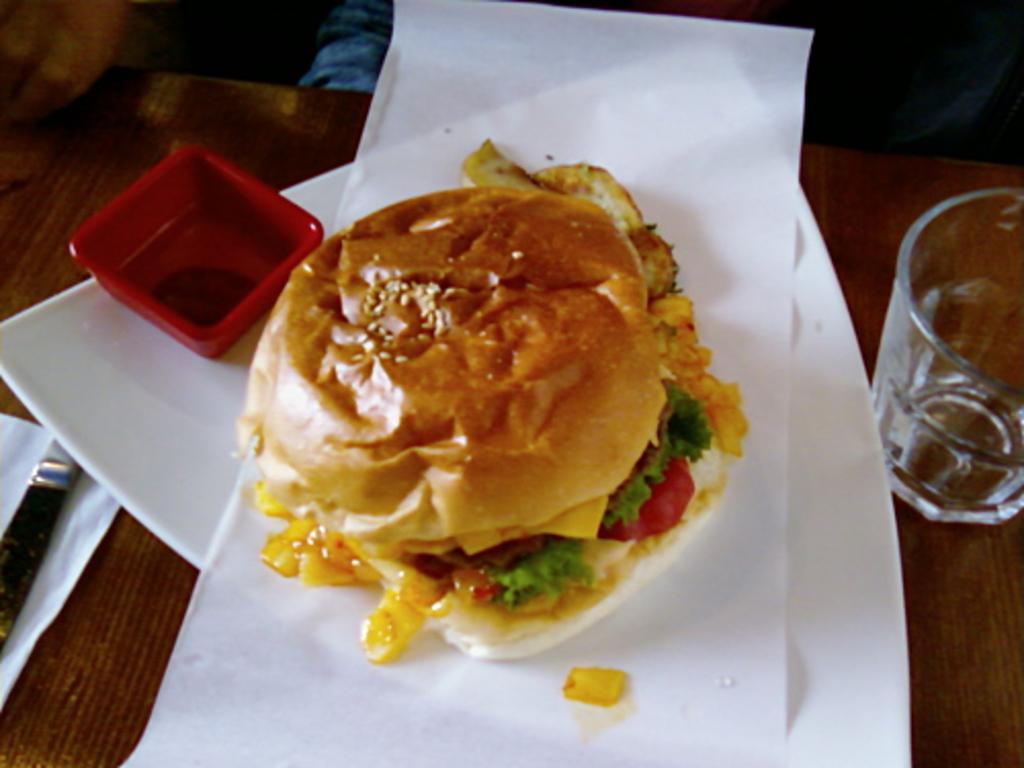In one or two sentences, can you explain what this image depicts? In this picture we can see the wooden platform, on this wooden platform we can see a plate, bowl, glass, food, knife and tissue papers. 